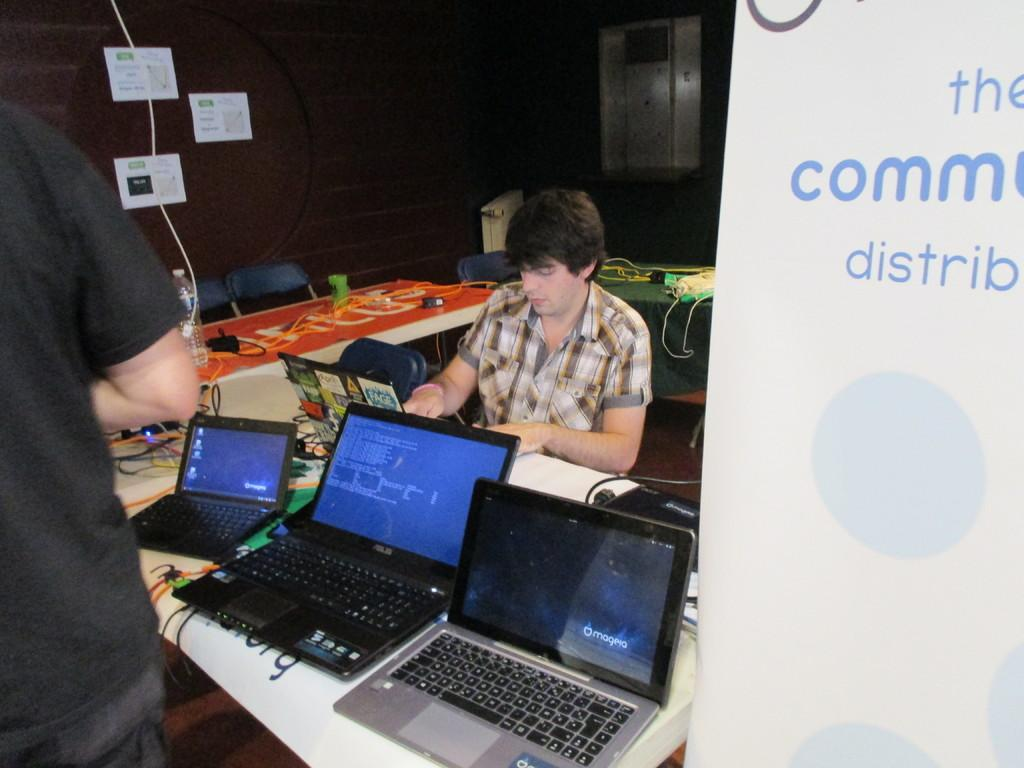<image>
Present a compact description of the photo's key features. People working on Magenta computers gather in a room. 